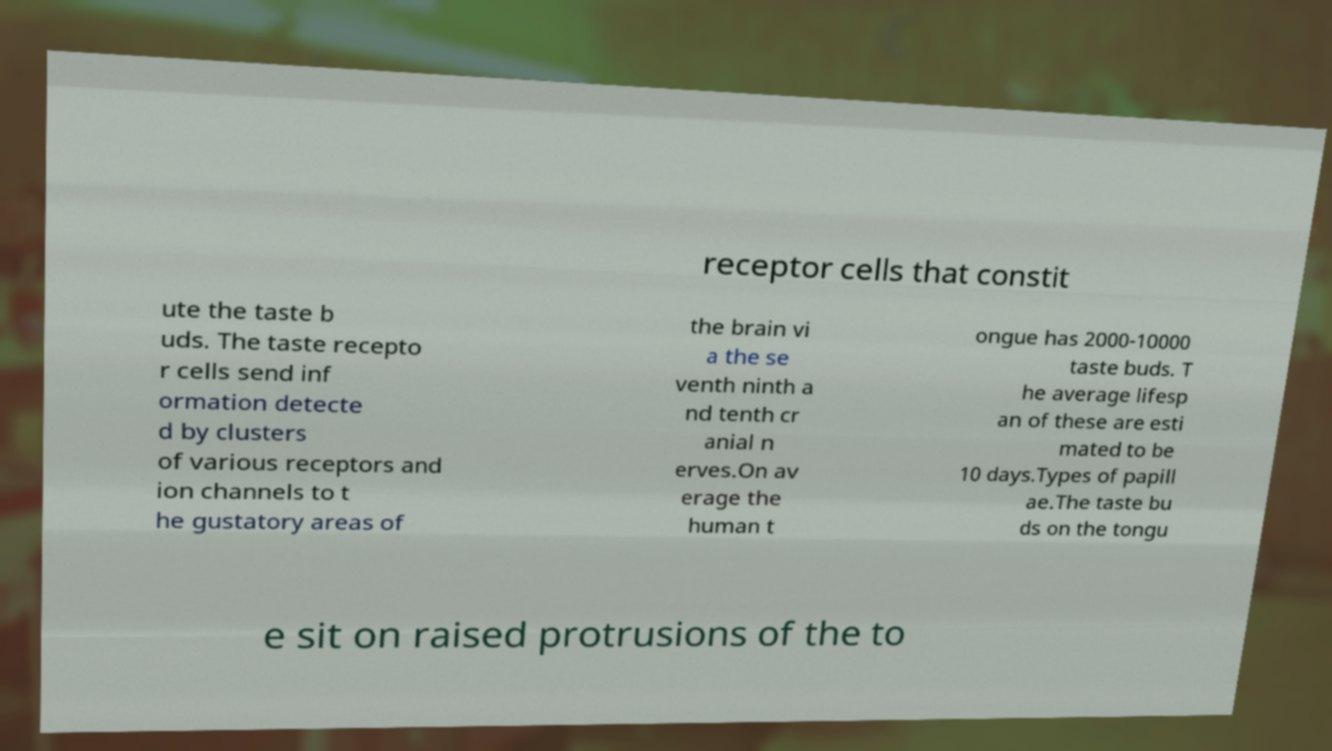Can you read and provide the text displayed in the image?This photo seems to have some interesting text. Can you extract and type it out for me? receptor cells that constit ute the taste b uds. The taste recepto r cells send inf ormation detecte d by clusters of various receptors and ion channels to t he gustatory areas of the brain vi a the se venth ninth a nd tenth cr anial n erves.On av erage the human t ongue has 2000-10000 taste buds. T he average lifesp an of these are esti mated to be 10 days.Types of papill ae.The taste bu ds on the tongu e sit on raised protrusions of the to 